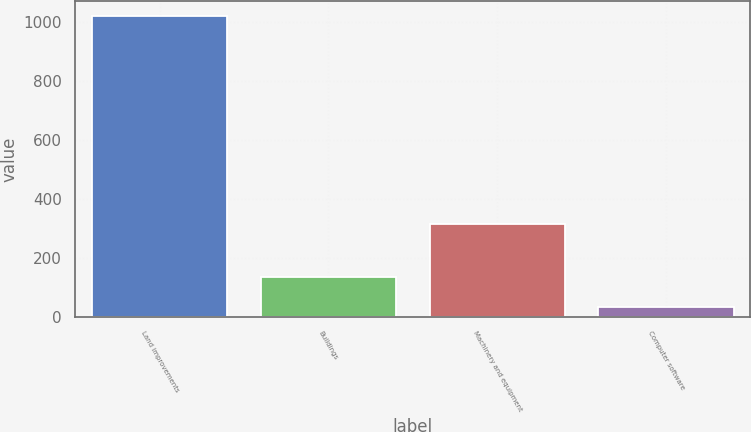<chart> <loc_0><loc_0><loc_500><loc_500><bar_chart><fcel>Land improvements<fcel>Buildings<fcel>Machinery and equipment<fcel>Computer software<nl><fcel>1020<fcel>133.5<fcel>315<fcel>35<nl></chart> 